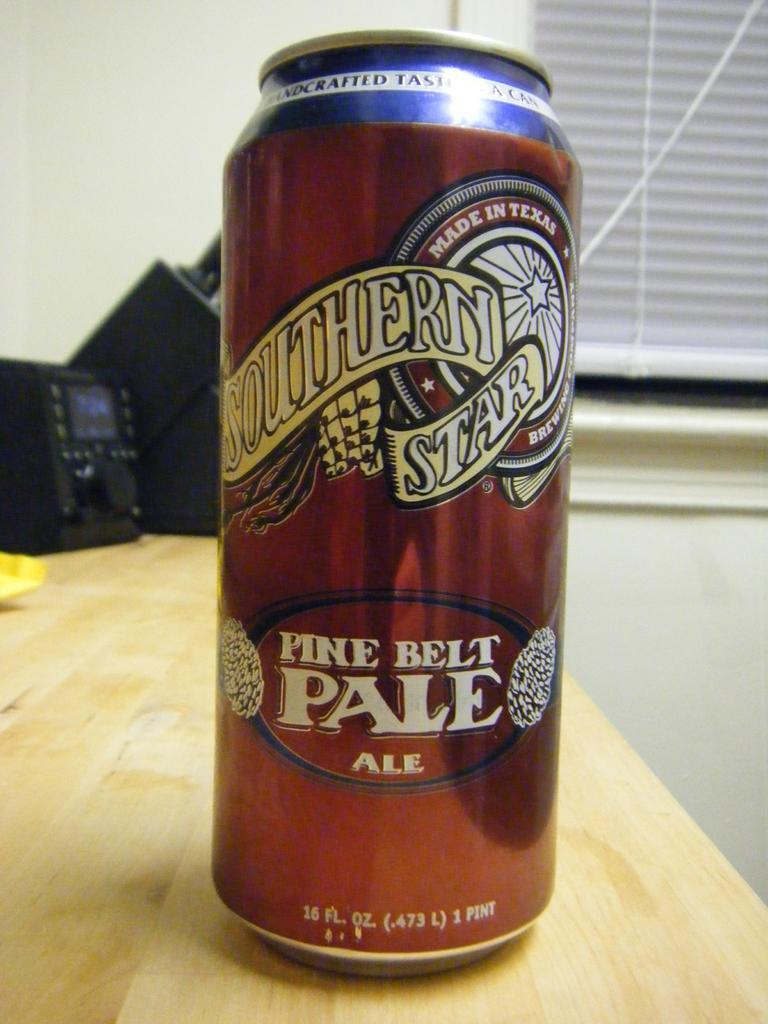<image>
Write a terse but informative summary of the picture. A can of Southern Star Pine Belt pale ale. 